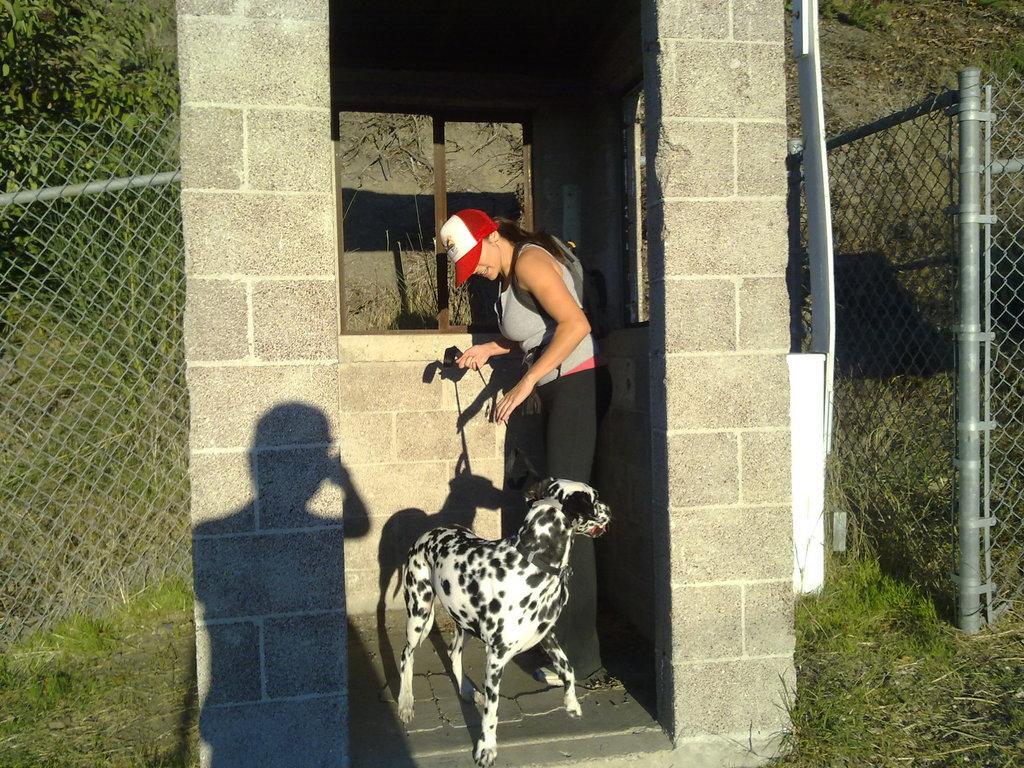Please provide a concise description of this image. In this picture we can see woman wore cap and holding dog with the rope and beside to her we can see pillar, net fence, plant, tree with pole. 